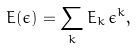Convert formula to latex. <formula><loc_0><loc_0><loc_500><loc_500>E ( \epsilon ) = \sum _ { k } E _ { k } \, \epsilon ^ { k } ,</formula> 